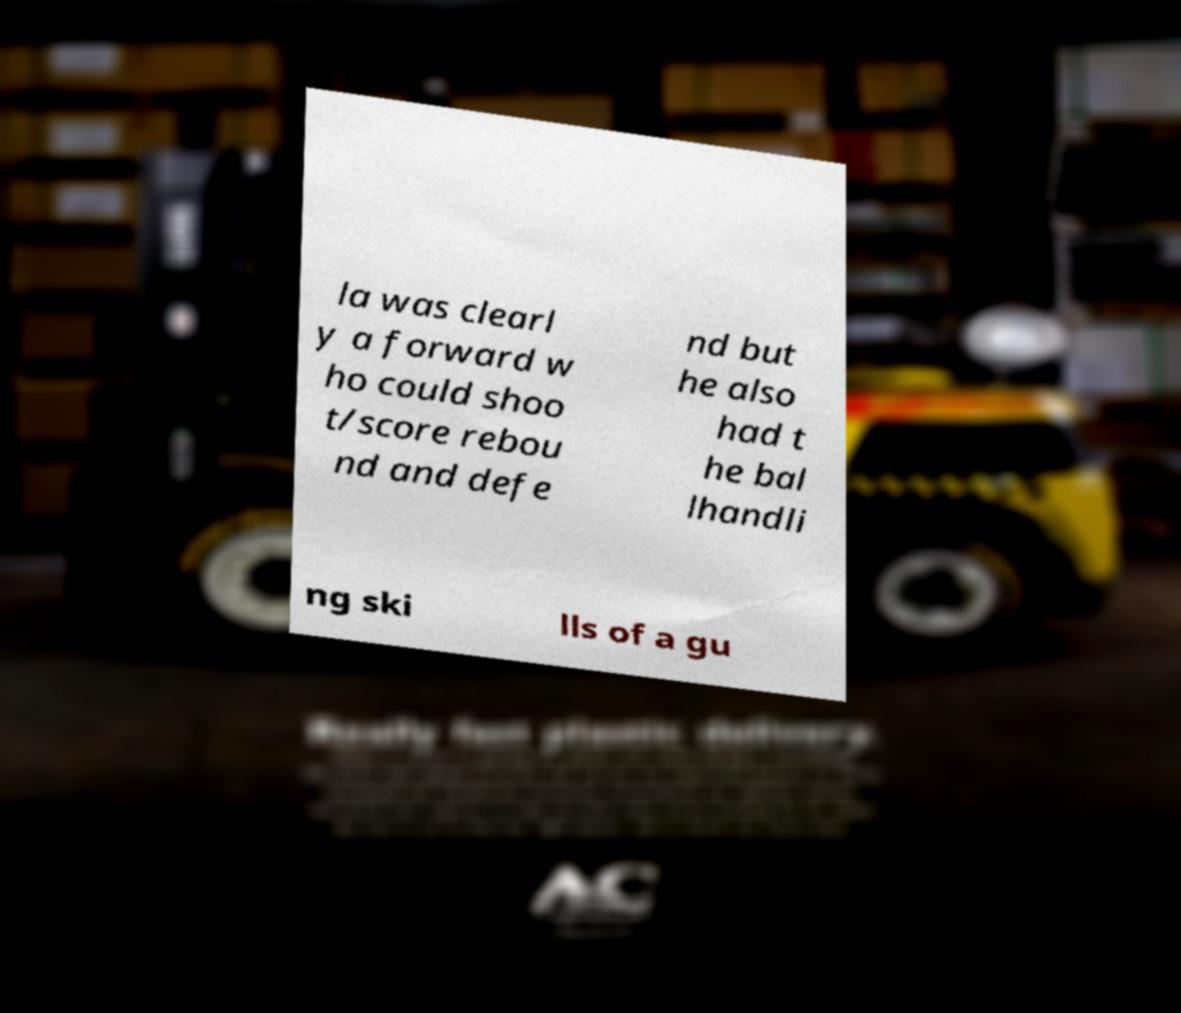Can you accurately transcribe the text from the provided image for me? la was clearl y a forward w ho could shoo t/score rebou nd and defe nd but he also had t he bal lhandli ng ski lls of a gu 